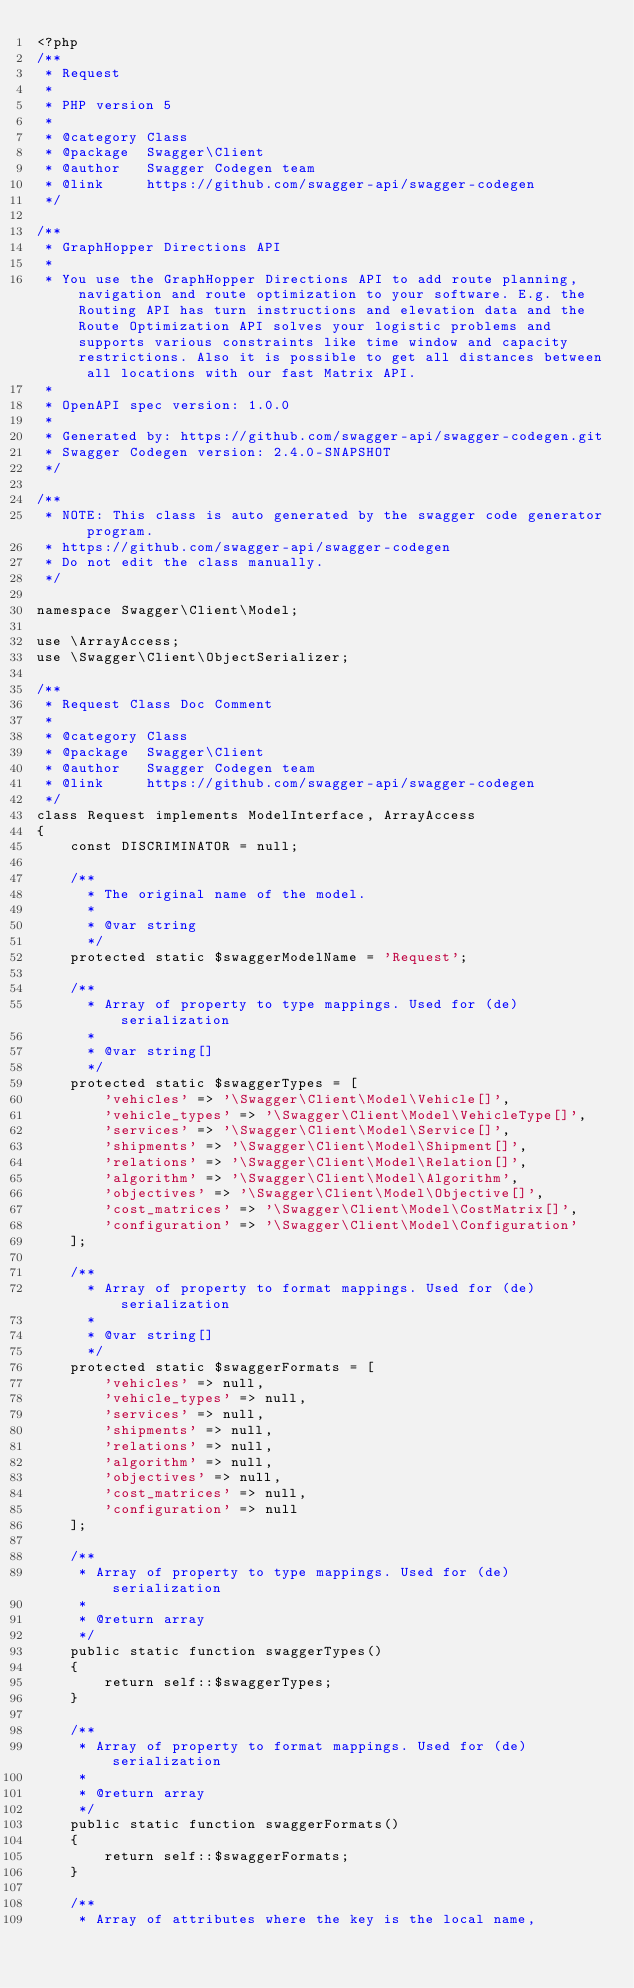Convert code to text. <code><loc_0><loc_0><loc_500><loc_500><_PHP_><?php
/**
 * Request
 *
 * PHP version 5
 *
 * @category Class
 * @package  Swagger\Client
 * @author   Swagger Codegen team
 * @link     https://github.com/swagger-api/swagger-codegen
 */

/**
 * GraphHopper Directions API
 *
 * You use the GraphHopper Directions API to add route planning, navigation and route optimization to your software. E.g. the Routing API has turn instructions and elevation data and the Route Optimization API solves your logistic problems and supports various constraints like time window and capacity restrictions. Also it is possible to get all distances between all locations with our fast Matrix API.
 *
 * OpenAPI spec version: 1.0.0
 * 
 * Generated by: https://github.com/swagger-api/swagger-codegen.git
 * Swagger Codegen version: 2.4.0-SNAPSHOT
 */

/**
 * NOTE: This class is auto generated by the swagger code generator program.
 * https://github.com/swagger-api/swagger-codegen
 * Do not edit the class manually.
 */

namespace Swagger\Client\Model;

use \ArrayAccess;
use \Swagger\Client\ObjectSerializer;

/**
 * Request Class Doc Comment
 *
 * @category Class
 * @package  Swagger\Client
 * @author   Swagger Codegen team
 * @link     https://github.com/swagger-api/swagger-codegen
 */
class Request implements ModelInterface, ArrayAccess
{
    const DISCRIMINATOR = null;

    /**
      * The original name of the model.
      *
      * @var string
      */
    protected static $swaggerModelName = 'Request';

    /**
      * Array of property to type mappings. Used for (de)serialization
      *
      * @var string[]
      */
    protected static $swaggerTypes = [
        'vehicles' => '\Swagger\Client\Model\Vehicle[]',
        'vehicle_types' => '\Swagger\Client\Model\VehicleType[]',
        'services' => '\Swagger\Client\Model\Service[]',
        'shipments' => '\Swagger\Client\Model\Shipment[]',
        'relations' => '\Swagger\Client\Model\Relation[]',
        'algorithm' => '\Swagger\Client\Model\Algorithm',
        'objectives' => '\Swagger\Client\Model\Objective[]',
        'cost_matrices' => '\Swagger\Client\Model\CostMatrix[]',
        'configuration' => '\Swagger\Client\Model\Configuration'
    ];

    /**
      * Array of property to format mappings. Used for (de)serialization
      *
      * @var string[]
      */
    protected static $swaggerFormats = [
        'vehicles' => null,
        'vehicle_types' => null,
        'services' => null,
        'shipments' => null,
        'relations' => null,
        'algorithm' => null,
        'objectives' => null,
        'cost_matrices' => null,
        'configuration' => null
    ];

    /**
     * Array of property to type mappings. Used for (de)serialization
     *
     * @return array
     */
    public static function swaggerTypes()
    {
        return self::$swaggerTypes;
    }

    /**
     * Array of property to format mappings. Used for (de)serialization
     *
     * @return array
     */
    public static function swaggerFormats()
    {
        return self::$swaggerFormats;
    }

    /**
     * Array of attributes where the key is the local name,</code> 